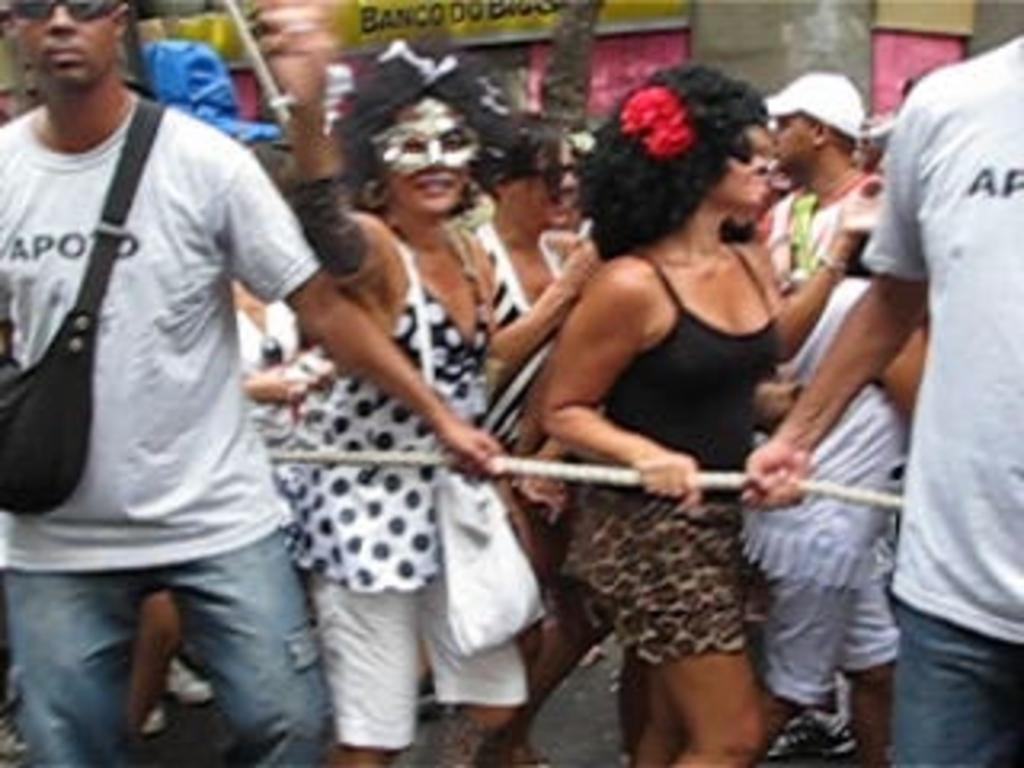What is happening in the image? There are people standing in the image. Can you describe the man on the left side? The man on the left side is carrying a bag. What object can be seen in the image that is typically used for tying or securing things? There is a rope in the image. What protective measure is the woman in the image taking? The woman in the image is wearing a mask. What subject is the man on the left side teaching in the image? There is no indication in the image that the man is teaching a subject. What religious belief does the rope in the image represent? The image does not depict any religious beliefs, and the rope is simply an object in the scene. 